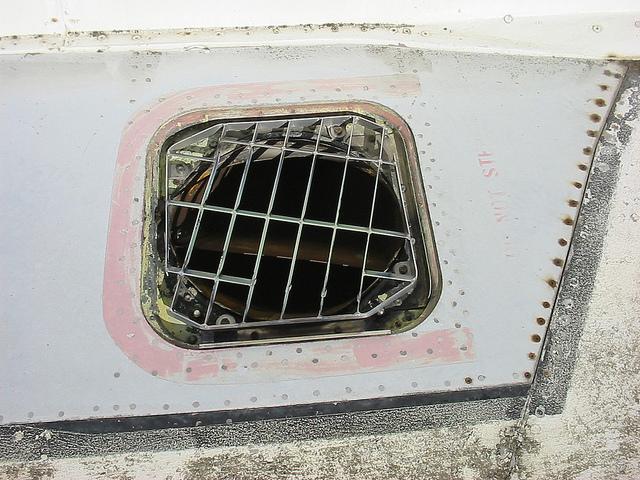Does the metal look rusty?
Quick response, please. Yes. Is this an oven?
Concise answer only. No. What is the grate for?
Quick response, please. Drainage. Is this on a military vehicle?
Answer briefly. No. 